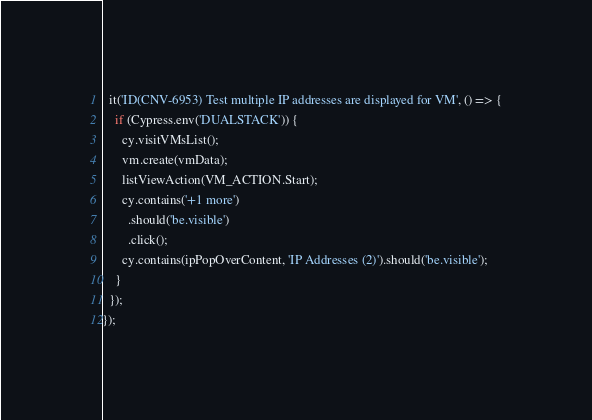<code> <loc_0><loc_0><loc_500><loc_500><_TypeScript_>
  it('ID(CNV-6953) Test multiple IP addresses are displayed for VM', () => {
    if (Cypress.env('DUALSTACK')) {
      cy.visitVMsList();
      vm.create(vmData);
      listViewAction(VM_ACTION.Start);
      cy.contains('+1 more')
        .should('be.visible')
        .click();
      cy.contains(ipPopOverContent, 'IP Addresses (2)').should('be.visible');
    }
  });
});
</code> 